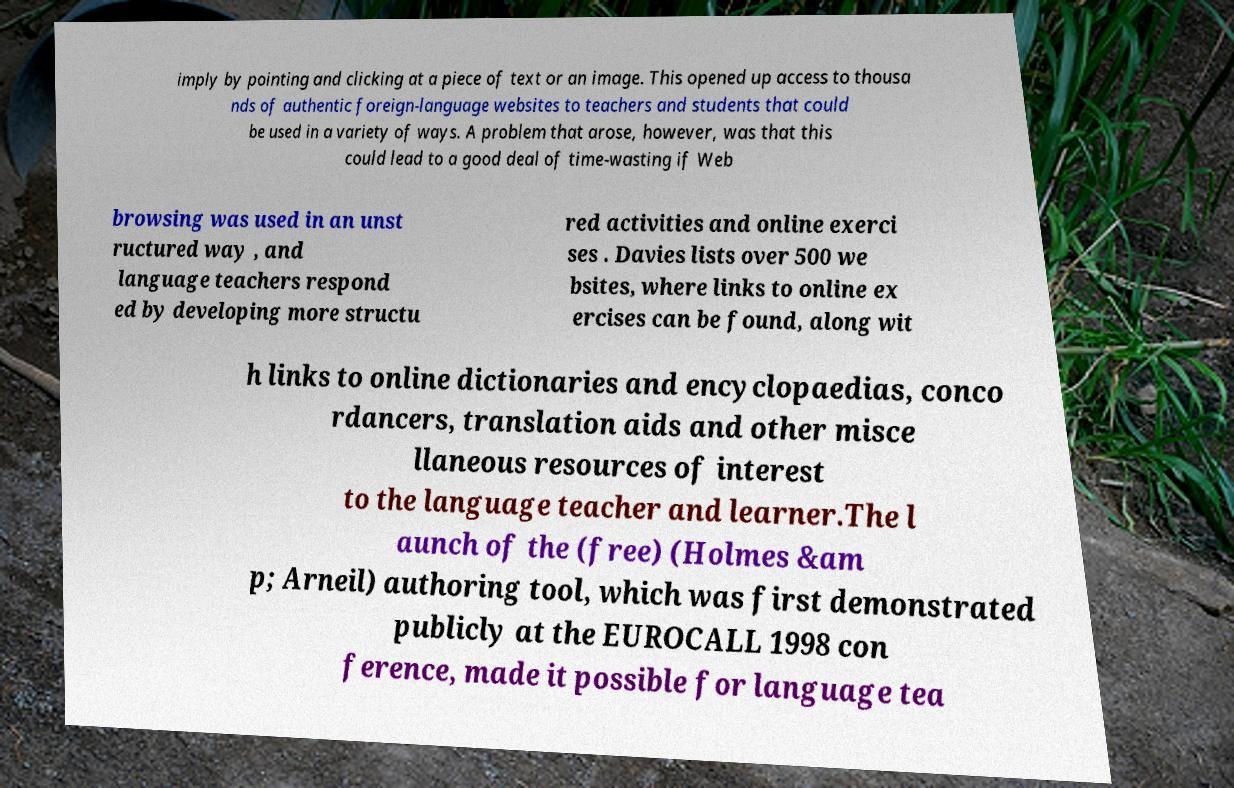Can you accurately transcribe the text from the provided image for me? imply by pointing and clicking at a piece of text or an image. This opened up access to thousa nds of authentic foreign-language websites to teachers and students that could be used in a variety of ways. A problem that arose, however, was that this could lead to a good deal of time-wasting if Web browsing was used in an unst ructured way , and language teachers respond ed by developing more structu red activities and online exerci ses . Davies lists over 500 we bsites, where links to online ex ercises can be found, along wit h links to online dictionaries and encyclopaedias, conco rdancers, translation aids and other misce llaneous resources of interest to the language teacher and learner.The l aunch of the (free) (Holmes &am p; Arneil) authoring tool, which was first demonstrated publicly at the EUROCALL 1998 con ference, made it possible for language tea 